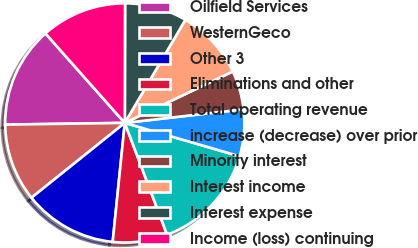Convert chart to OTSL. <chart><loc_0><loc_0><loc_500><loc_500><pie_chart><fcel>Oilfield Services<fcel>WesternGeco<fcel>Other 3<fcel>Eliminations and other<fcel>Total operating revenue<fcel>increase (decrease) over prior<fcel>Minority interest<fcel>Interest income<fcel>Interest expense<fcel>Income (loss) continuing<nl><fcel>13.68%<fcel>10.53%<fcel>12.63%<fcel>7.37%<fcel>14.74%<fcel>6.32%<fcel>5.26%<fcel>9.47%<fcel>8.42%<fcel>11.58%<nl></chart> 